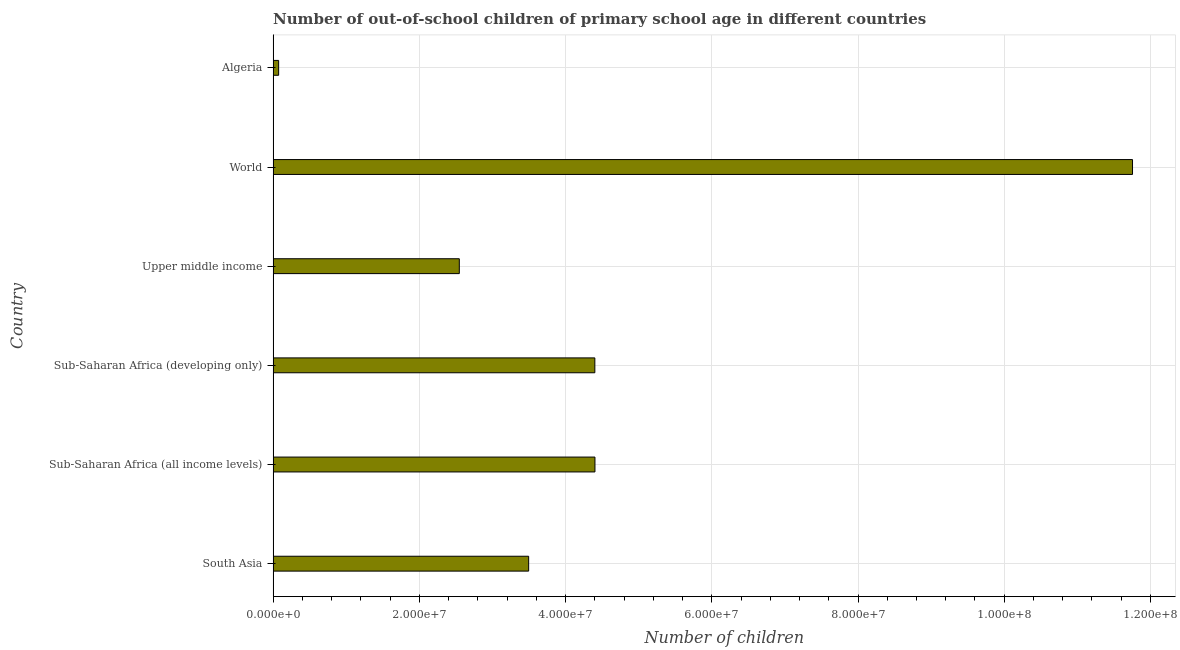Does the graph contain any zero values?
Ensure brevity in your answer.  No. Does the graph contain grids?
Make the answer very short. Yes. What is the title of the graph?
Your response must be concise. Number of out-of-school children of primary school age in different countries. What is the label or title of the X-axis?
Make the answer very short. Number of children. What is the label or title of the Y-axis?
Provide a succinct answer. Country. What is the number of out-of-school children in Sub-Saharan Africa (all income levels)?
Ensure brevity in your answer.  4.40e+07. Across all countries, what is the maximum number of out-of-school children?
Provide a succinct answer. 1.18e+08. Across all countries, what is the minimum number of out-of-school children?
Offer a very short reply. 7.55e+05. In which country was the number of out-of-school children minimum?
Provide a succinct answer. Algeria. What is the sum of the number of out-of-school children?
Provide a succinct answer. 2.67e+08. What is the difference between the number of out-of-school children in Sub-Saharan Africa (developing only) and World?
Offer a very short reply. -7.35e+07. What is the average number of out-of-school children per country?
Provide a succinct answer. 4.45e+07. What is the median number of out-of-school children?
Your response must be concise. 3.95e+07. What is the ratio of the number of out-of-school children in Sub-Saharan Africa (developing only) to that in Upper middle income?
Offer a very short reply. 1.73. Is the number of out-of-school children in Sub-Saharan Africa (all income levels) less than that in Sub-Saharan Africa (developing only)?
Provide a succinct answer. No. What is the difference between the highest and the second highest number of out-of-school children?
Offer a terse response. 7.35e+07. What is the difference between the highest and the lowest number of out-of-school children?
Your answer should be compact. 1.17e+08. In how many countries, is the number of out-of-school children greater than the average number of out-of-school children taken over all countries?
Offer a very short reply. 1. How many countries are there in the graph?
Offer a terse response. 6. Are the values on the major ticks of X-axis written in scientific E-notation?
Keep it short and to the point. Yes. What is the Number of children in South Asia?
Your answer should be compact. 3.50e+07. What is the Number of children of Sub-Saharan Africa (all income levels)?
Give a very brief answer. 4.40e+07. What is the Number of children in Sub-Saharan Africa (developing only)?
Your answer should be compact. 4.40e+07. What is the Number of children of Upper middle income?
Ensure brevity in your answer.  2.55e+07. What is the Number of children in World?
Make the answer very short. 1.18e+08. What is the Number of children in Algeria?
Offer a very short reply. 7.55e+05. What is the difference between the Number of children in South Asia and Sub-Saharan Africa (all income levels)?
Make the answer very short. -9.07e+06. What is the difference between the Number of children in South Asia and Sub-Saharan Africa (developing only)?
Give a very brief answer. -9.05e+06. What is the difference between the Number of children in South Asia and Upper middle income?
Your answer should be compact. 9.49e+06. What is the difference between the Number of children in South Asia and World?
Offer a very short reply. -8.26e+07. What is the difference between the Number of children in South Asia and Algeria?
Keep it short and to the point. 3.42e+07. What is the difference between the Number of children in Sub-Saharan Africa (all income levels) and Sub-Saharan Africa (developing only)?
Keep it short and to the point. 1.58e+04. What is the difference between the Number of children in Sub-Saharan Africa (all income levels) and Upper middle income?
Provide a short and direct response. 1.86e+07. What is the difference between the Number of children in Sub-Saharan Africa (all income levels) and World?
Provide a short and direct response. -7.35e+07. What is the difference between the Number of children in Sub-Saharan Africa (all income levels) and Algeria?
Provide a succinct answer. 4.33e+07. What is the difference between the Number of children in Sub-Saharan Africa (developing only) and Upper middle income?
Provide a succinct answer. 1.85e+07. What is the difference between the Number of children in Sub-Saharan Africa (developing only) and World?
Offer a very short reply. -7.35e+07. What is the difference between the Number of children in Sub-Saharan Africa (developing only) and Algeria?
Keep it short and to the point. 4.33e+07. What is the difference between the Number of children in Upper middle income and World?
Your answer should be compact. -9.21e+07. What is the difference between the Number of children in Upper middle income and Algeria?
Your answer should be compact. 2.47e+07. What is the difference between the Number of children in World and Algeria?
Make the answer very short. 1.17e+08. What is the ratio of the Number of children in South Asia to that in Sub-Saharan Africa (all income levels)?
Make the answer very short. 0.79. What is the ratio of the Number of children in South Asia to that in Sub-Saharan Africa (developing only)?
Your answer should be compact. 0.79. What is the ratio of the Number of children in South Asia to that in Upper middle income?
Offer a very short reply. 1.37. What is the ratio of the Number of children in South Asia to that in World?
Offer a terse response. 0.3. What is the ratio of the Number of children in South Asia to that in Algeria?
Offer a very short reply. 46.3. What is the ratio of the Number of children in Sub-Saharan Africa (all income levels) to that in Upper middle income?
Your answer should be compact. 1.73. What is the ratio of the Number of children in Sub-Saharan Africa (all income levels) to that in World?
Provide a succinct answer. 0.37. What is the ratio of the Number of children in Sub-Saharan Africa (all income levels) to that in Algeria?
Provide a succinct answer. 58.32. What is the ratio of the Number of children in Sub-Saharan Africa (developing only) to that in Upper middle income?
Your response must be concise. 1.73. What is the ratio of the Number of children in Sub-Saharan Africa (developing only) to that in World?
Offer a very short reply. 0.37. What is the ratio of the Number of children in Sub-Saharan Africa (developing only) to that in Algeria?
Your answer should be very brief. 58.3. What is the ratio of the Number of children in Upper middle income to that in World?
Ensure brevity in your answer.  0.22. What is the ratio of the Number of children in Upper middle income to that in Algeria?
Provide a succinct answer. 33.74. What is the ratio of the Number of children in World to that in Algeria?
Ensure brevity in your answer.  155.73. 